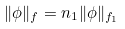<formula> <loc_0><loc_0><loc_500><loc_500>\| \phi \| _ { f } = n _ { 1 } \| \phi \| _ { f _ { 1 } }</formula> 